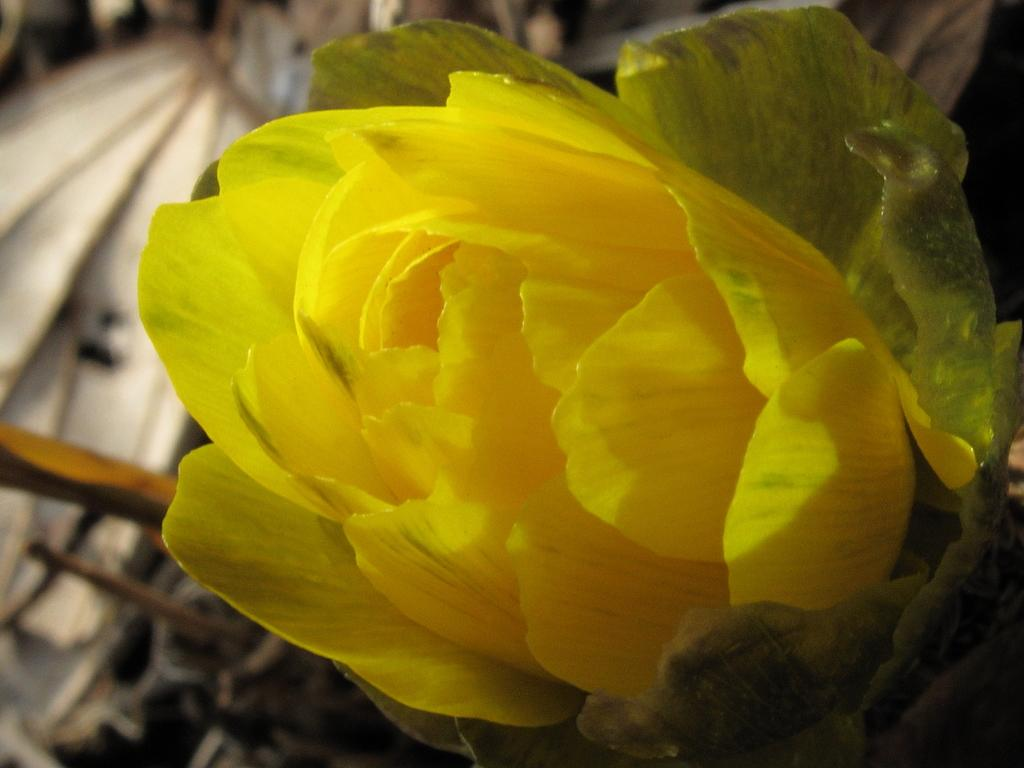What is the main subject of the image? There is a flower in the image. What color is the knee of the person holding the flower in the image? There is no person holding the flower in the image, and therefore no knee is present. What type of fruit is being used as a vase for the flower in the image? There is no fruit or vase present in the image; it only features a flower. 